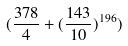<formula> <loc_0><loc_0><loc_500><loc_500>( \frac { 3 7 8 } { 4 } + ( \frac { 1 4 3 } { 1 0 } ) ^ { 1 9 6 } )</formula> 